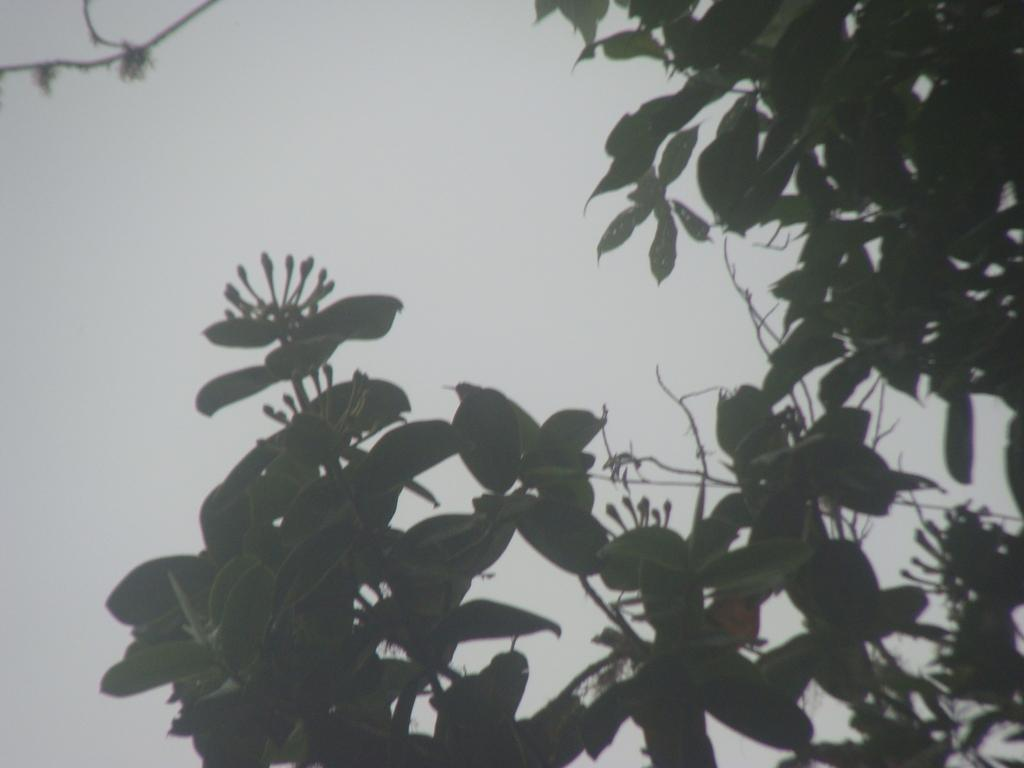What is the primary subject of the image? The primary subject of the image is many leaves. Are there any other features visible on the leaves? Yes, there are buds on the stems in the image. What can be seen in the background of the image? The sky is visible in the background of the image. What type of vessel is being offered to the apple in the image? There is no vessel or apple present in the image; it only features leaves and buds on stems. 